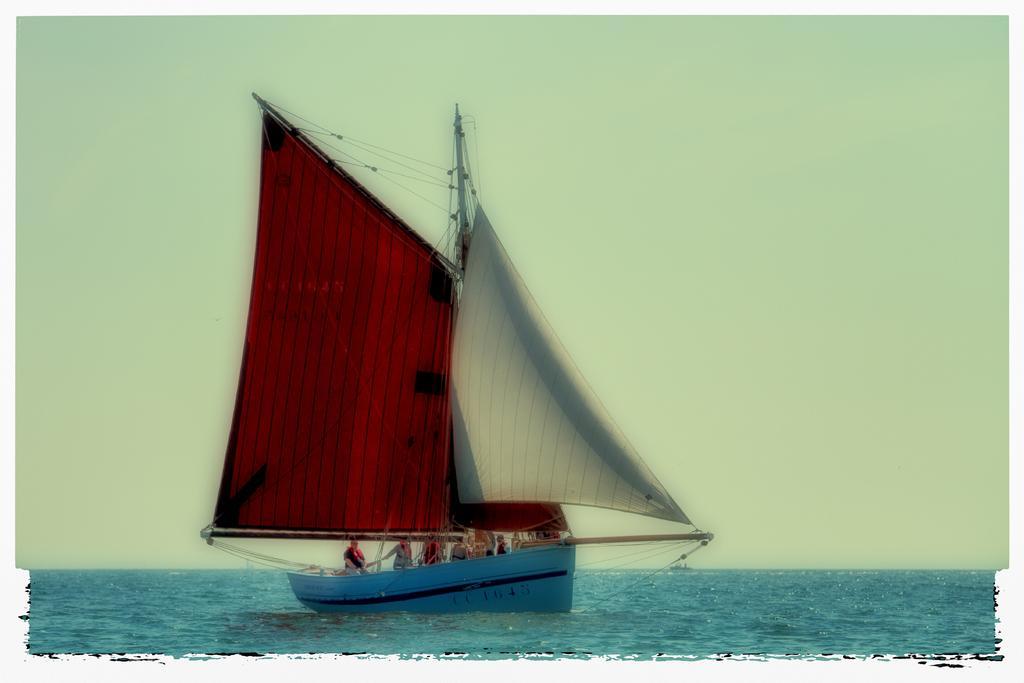Could you give a brief overview of what you see in this image? In this image there is the sea, there is a boat on the sea, there are person in the boat, at the background of the image there is the sky. 